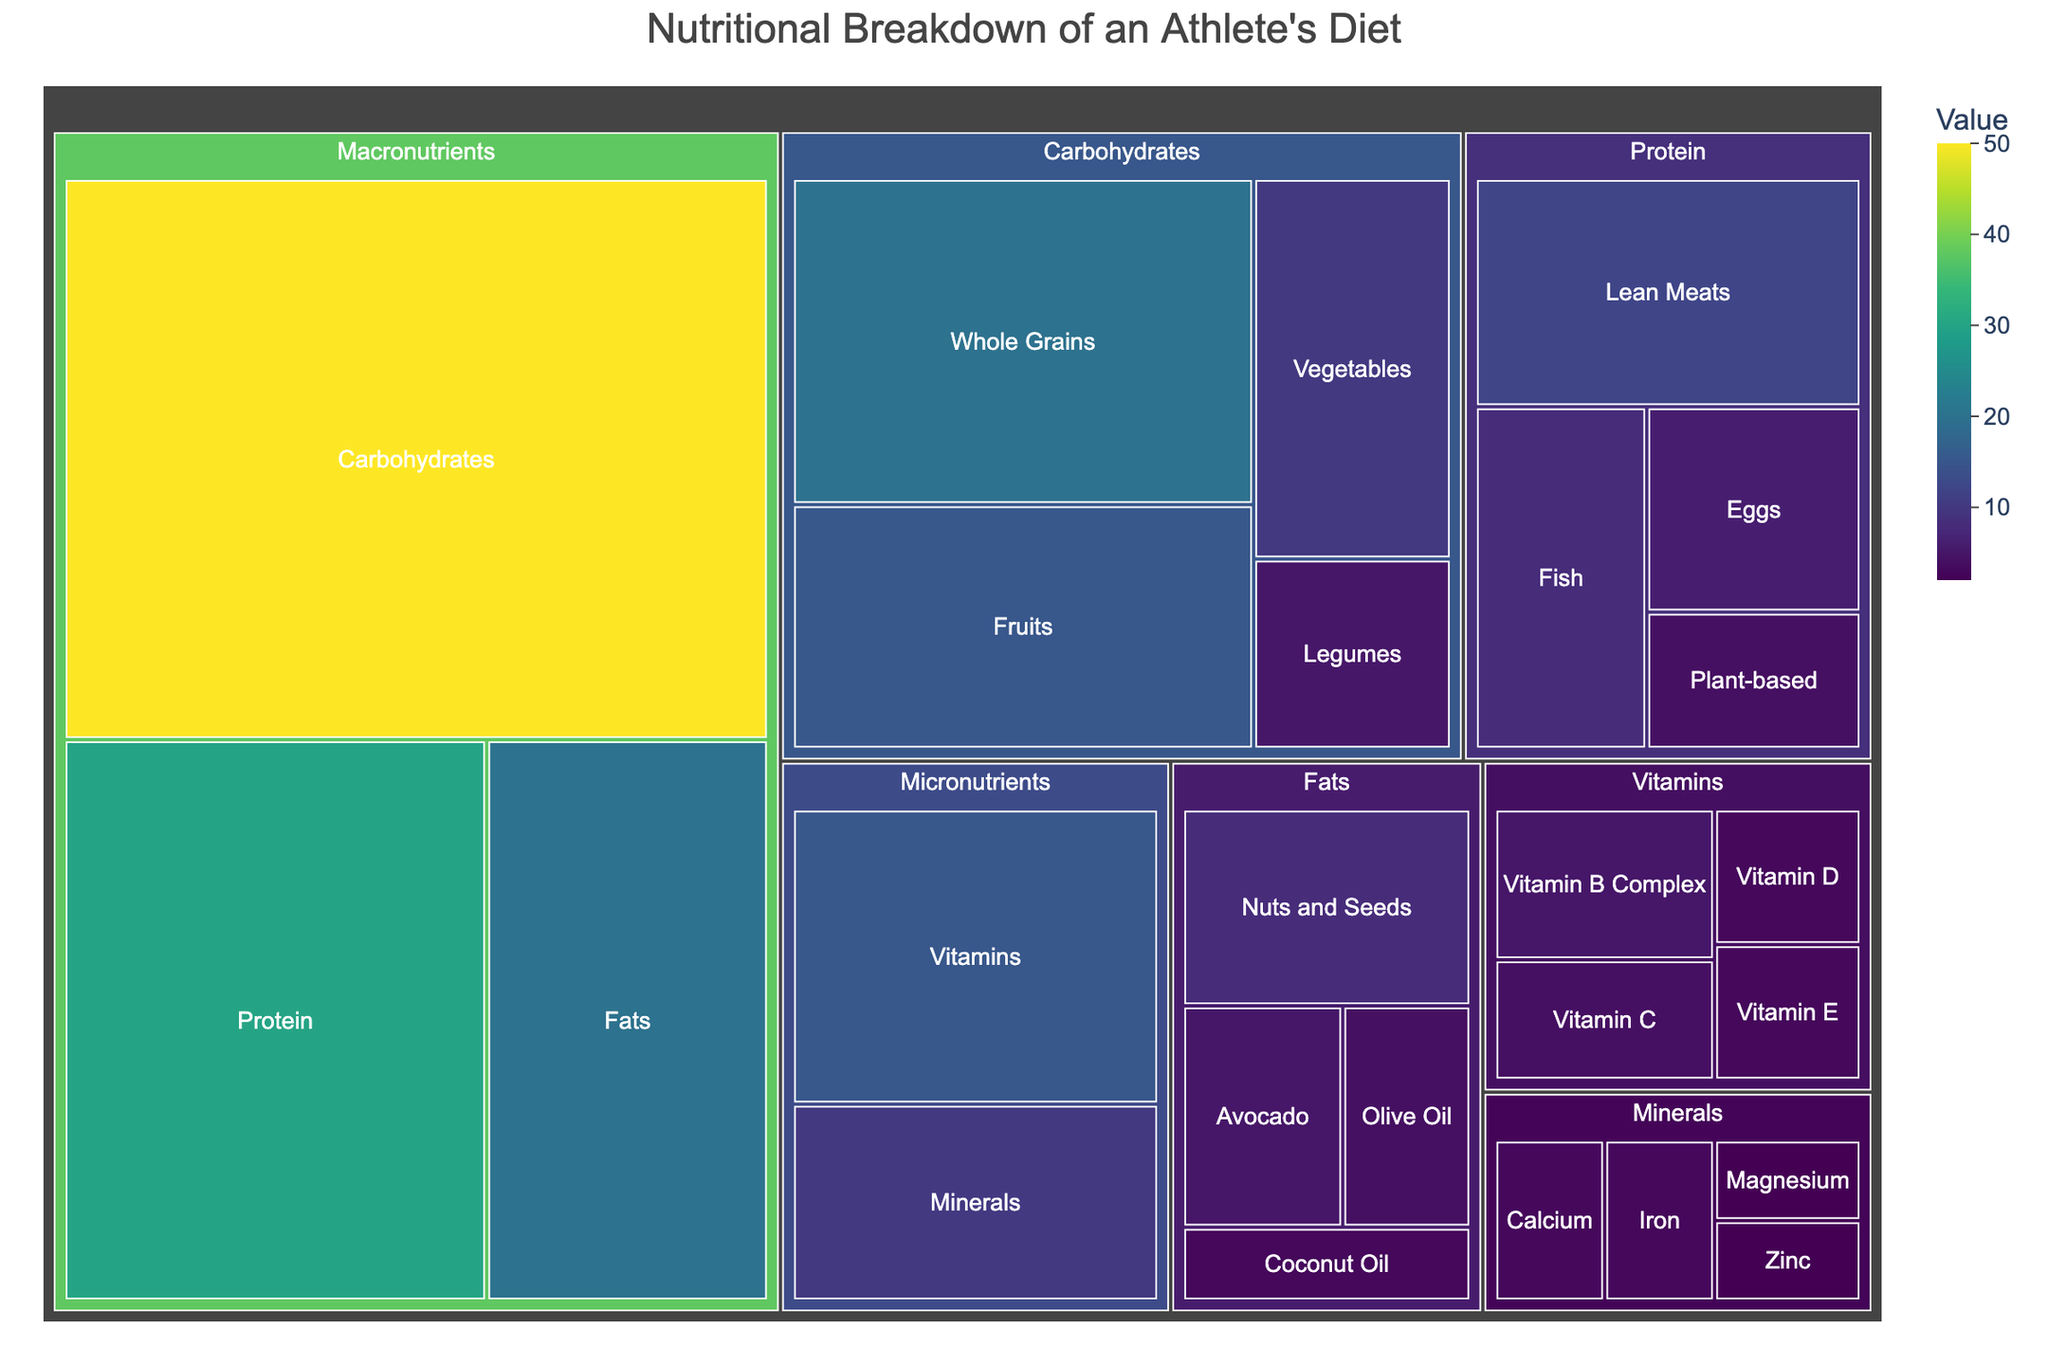What's the title of the treemap? The title is displayed at the top of the figure, which usually indicates the main subject of the visualization. In this case, it's "Nutritional Breakdown of an Athlete's Diet".
Answer: Nutritional Breakdown of an Athlete's Diet Which macronutrient has the highest value? In the treemap, each macronutrient is represented by different sizes of rectangles. The one with the largest area has the highest value. Among Protein, Carbohydrates, and Fats, Carbohydrates has the largest area.
Answer: Carbohydrates What is the value of vitamins in the micronutrients category? Within the micronutrients category, each subcategory like Vitamins and Minerals has its own segment. The segment for Vitamins has a label indicating a value of 15.
Answer: 15 How does the value of Fats compare to the value of Protein? The visualization shows the values for both Fats and Protein within the macronutrients category. Fats has a value of 20, and Protein has a value of 30. By comparing these values, we see that Protein has a higher value.
Answer: Protein has a higher value than Fats What is the total value of the protein subcategories? The total value of Protein subcategories (Lean Meats, Fish, Eggs, Plant-based) is the sum of their individual values. Adding them up: 12 (Lean Meats) + 8 (Fish) + 6 (Eggs) + 4 (Plant-based) = 30.
Answer: 30 Which has more value, Vitamins or Minerals? Both Vitamins and Minerals are subcategories under Micronutrients. Comparing their values directly from the treemap, Vitamins has a value of 15, whereas Minerals has a value of 10.
Answer: Vitamins What subcategory has the highest value within Carbohydrates? The Carbohydrates subcategory contains Whole Grains, Fruits, Vegetables, and Legumes. Among these, Whole Grains has the highest value of 20.
Answer: Whole Grains Calculate the difference between the total value of Macronutrients and Micronutrients. Summing the values for Macronutrients (30 + 50 + 20 = 100) and Micronutrients (15 + 10 = 25), the difference is 100 - 25 = 75.
Answer: 75 Which fat source has the least value? Within the Fats subcategory, Nuts and Seeds, Avocado, Olive Oil, and Coconut Oil are listed. Among these, Coconut Oil has the smallest area and value of 3.
Answer: Coconut Oil What is the value ratio of Carbohydrates to Protein? From the treemap, Carbohydrates has a value of 50, and Protein has a value of 30. The ratio is calculated as 50 ÷ 30 which simplifies to 5/3 or approximately 1.67.
Answer: Approximately 1.67 